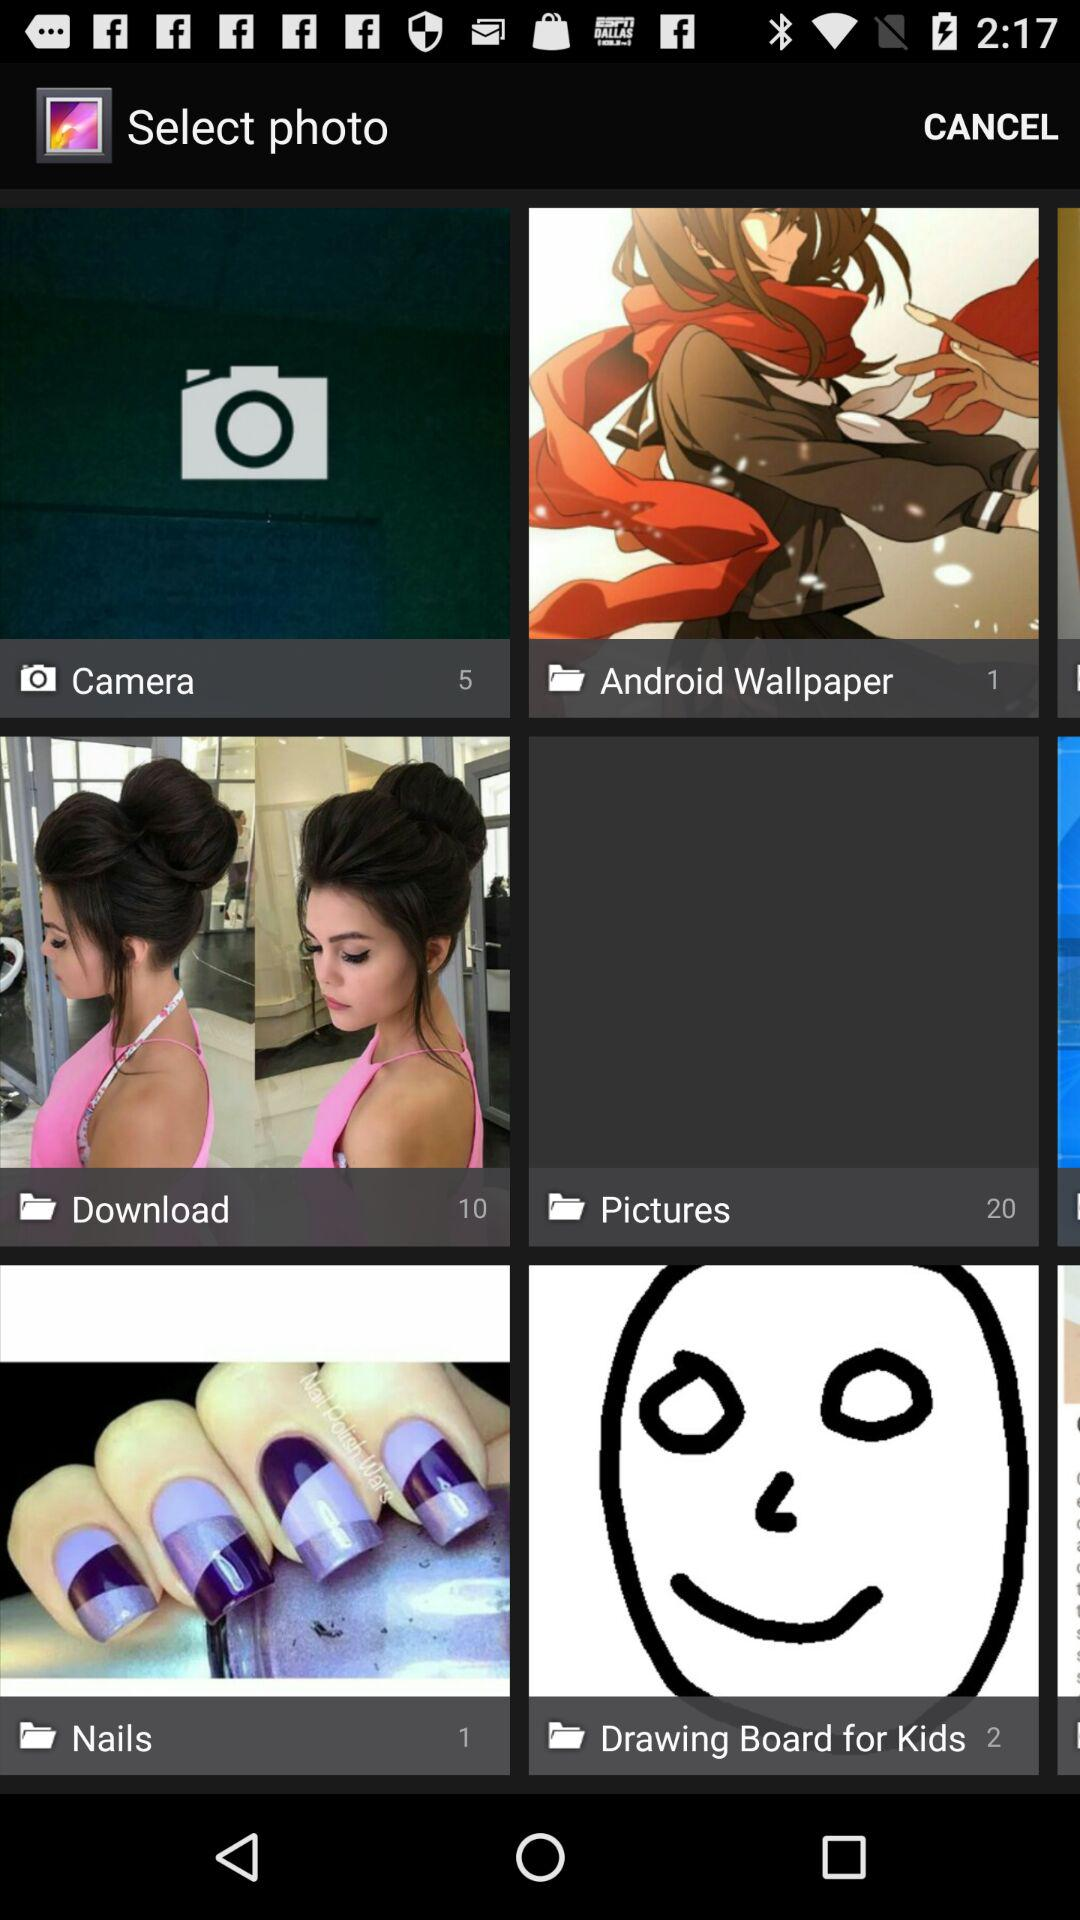How many photos are there in the "Android Wallpaper" folder? There is 1 photo in the "Android Wallpaper" folder. 